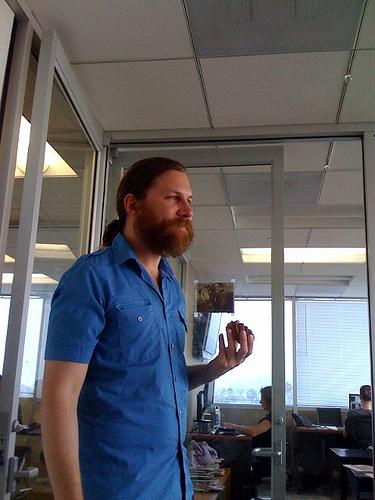What office reprieve does this man avail himself of? doughnut 